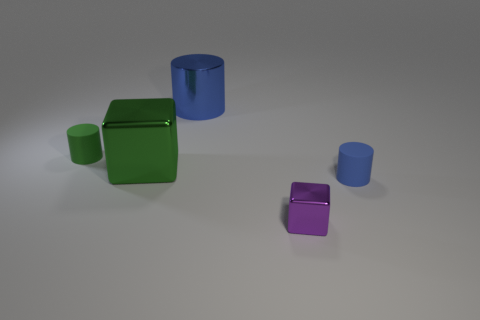Add 2 blue things. How many objects exist? 7 Subtract all cubes. How many objects are left? 3 Add 3 purple metal objects. How many purple metal objects are left? 4 Add 4 green matte things. How many green matte things exist? 5 Subtract 0 green balls. How many objects are left? 5 Subtract all yellow cylinders. Subtract all blue cylinders. How many objects are left? 3 